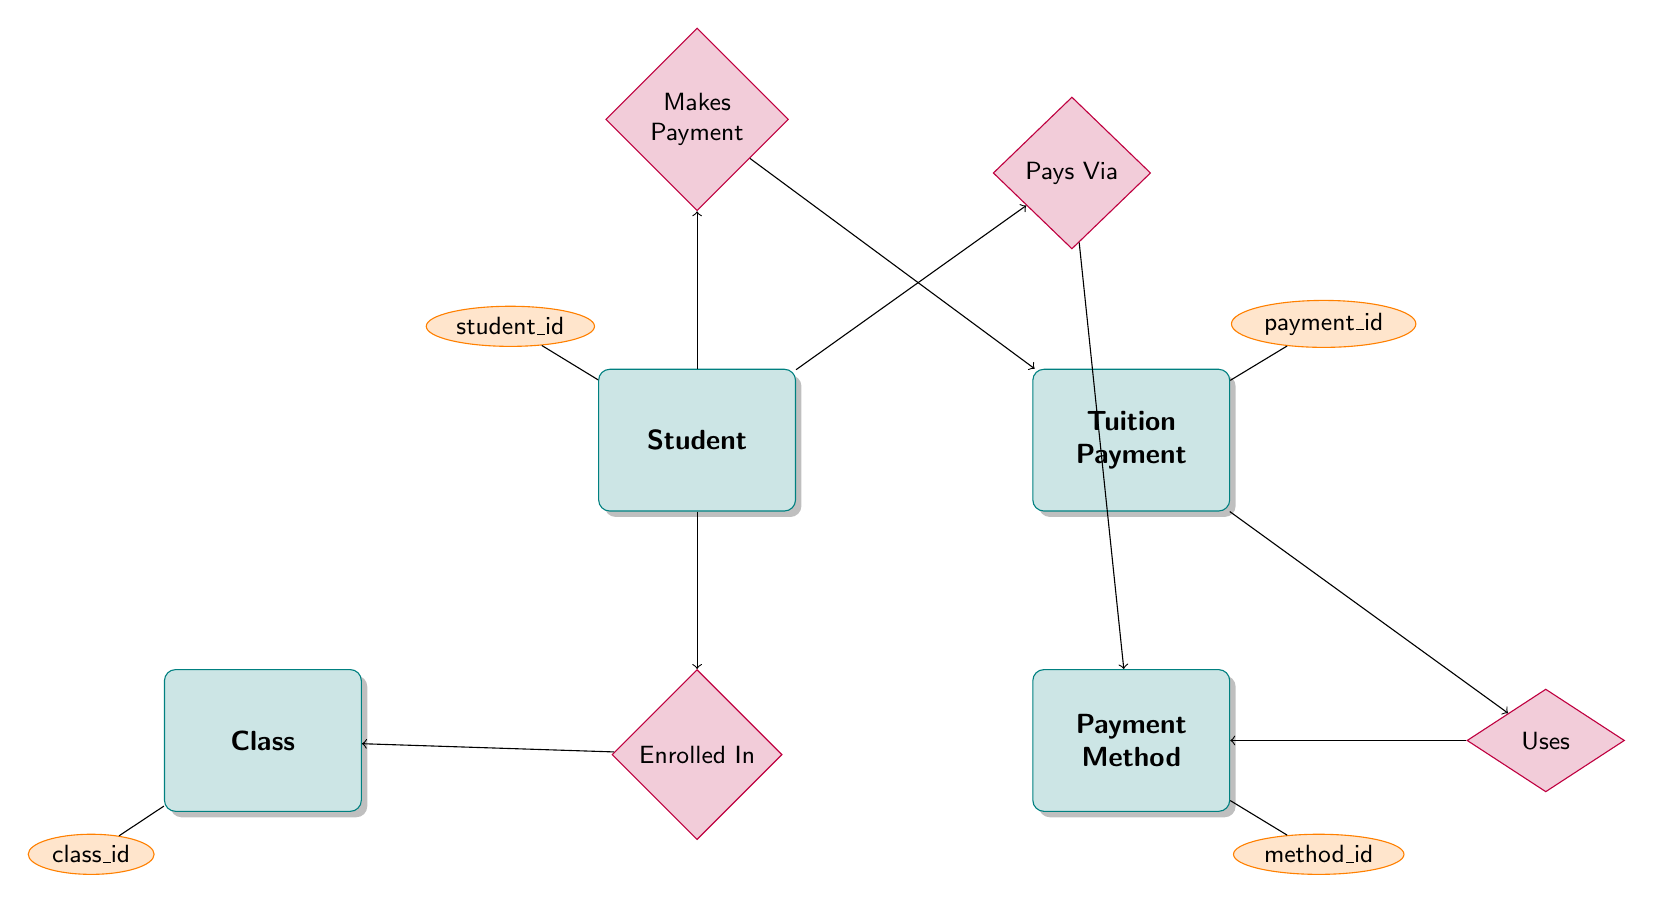What entities are present in the diagram? The diagram lists four entities: Student, Tuition Payment, Payment Method, and Class.
Answer: Student, Tuition Payment, Payment Method, Class How many relationships are depicted in the diagram? There are four relationships illustrated in the diagram: Enrolled In, Pays Via, Makes Payment, and Payment Uses Method.
Answer: 4 What attribute is associated with the Tuition Payment entity? The Tuition Payment entity has several attributes, including payment_id, amount, payment_date, and due_date; however, payment_id is highlighted in the diagram as its key attribute.
Answer: payment_id Which entity is connected to the relationship 'Enrolled In'? The relationship 'Enrolled In' connects the Student entity to the Class entity, indicating that students are enrolled in classes.
Answer: Class What can the Payment Method entity detail? The Payment Method entity includes details about various payment methods used by students, with method_name as a significant attribute among others like method_id and details.
Answer: method_name Which entity is connected to 'Makes Payment'? The 'Makes Payment' relationship connects the Student entity to the Tuition Payment entity, showing that students make tuition payments.
Answer: Tuition Payment How many attributes does the Student entity have? The Student entity has five attributes: student_id, first_name, last_name, email, and phone_number; therefore, it totals to five.
Answer: 5 What relationship is nearest to the Payment Method entity? The relationship 'Pays Via' is nearest to the Payment Method entity, indicating how students pay using different methods.
Answer: Pays Via Which relationship describes how a tuition payment is processed through a method? The relationship 'Payment Uses Method' describes how a tuition payment is processed through a payment method, outlining the connection between the Tuition Payment entity and the Payment Method entity.
Answer: Payment Uses Method 